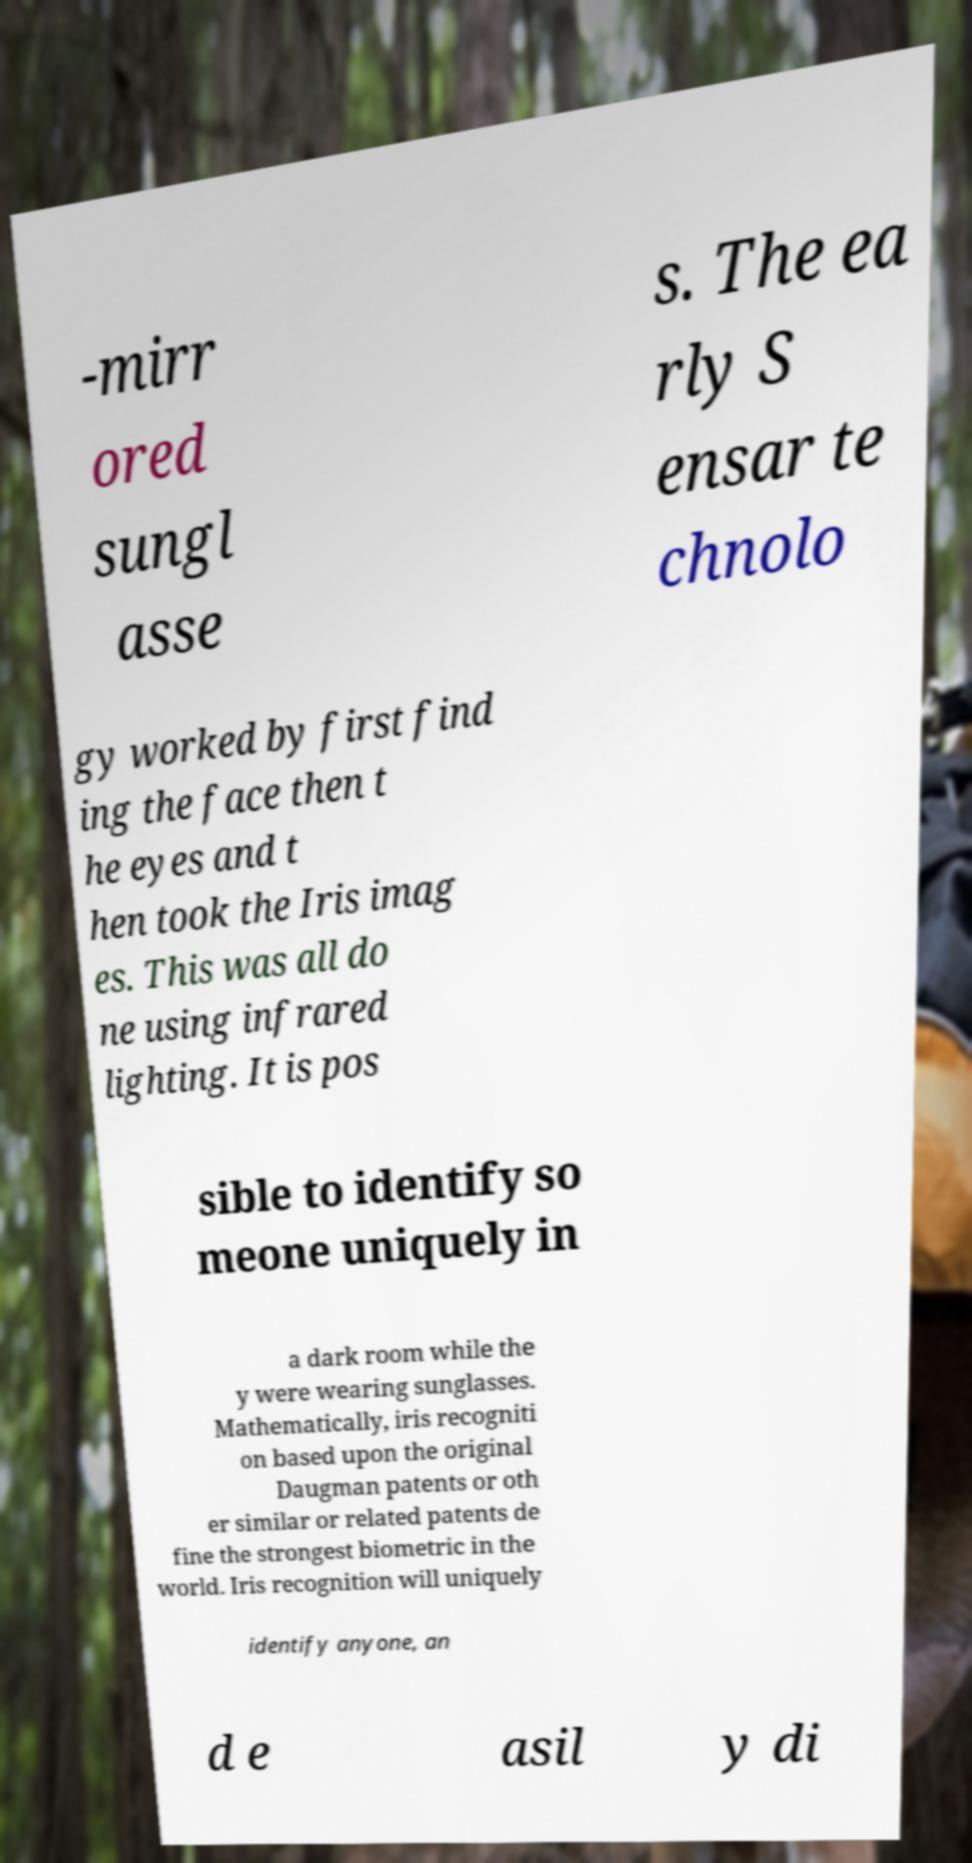For documentation purposes, I need the text within this image transcribed. Could you provide that? -mirr ored sungl asse s. The ea rly S ensar te chnolo gy worked by first find ing the face then t he eyes and t hen took the Iris imag es. This was all do ne using infrared lighting. It is pos sible to identify so meone uniquely in a dark room while the y were wearing sunglasses. Mathematically, iris recogniti on based upon the original Daugman patents or oth er similar or related patents de fine the strongest biometric in the world. Iris recognition will uniquely identify anyone, an d e asil y di 